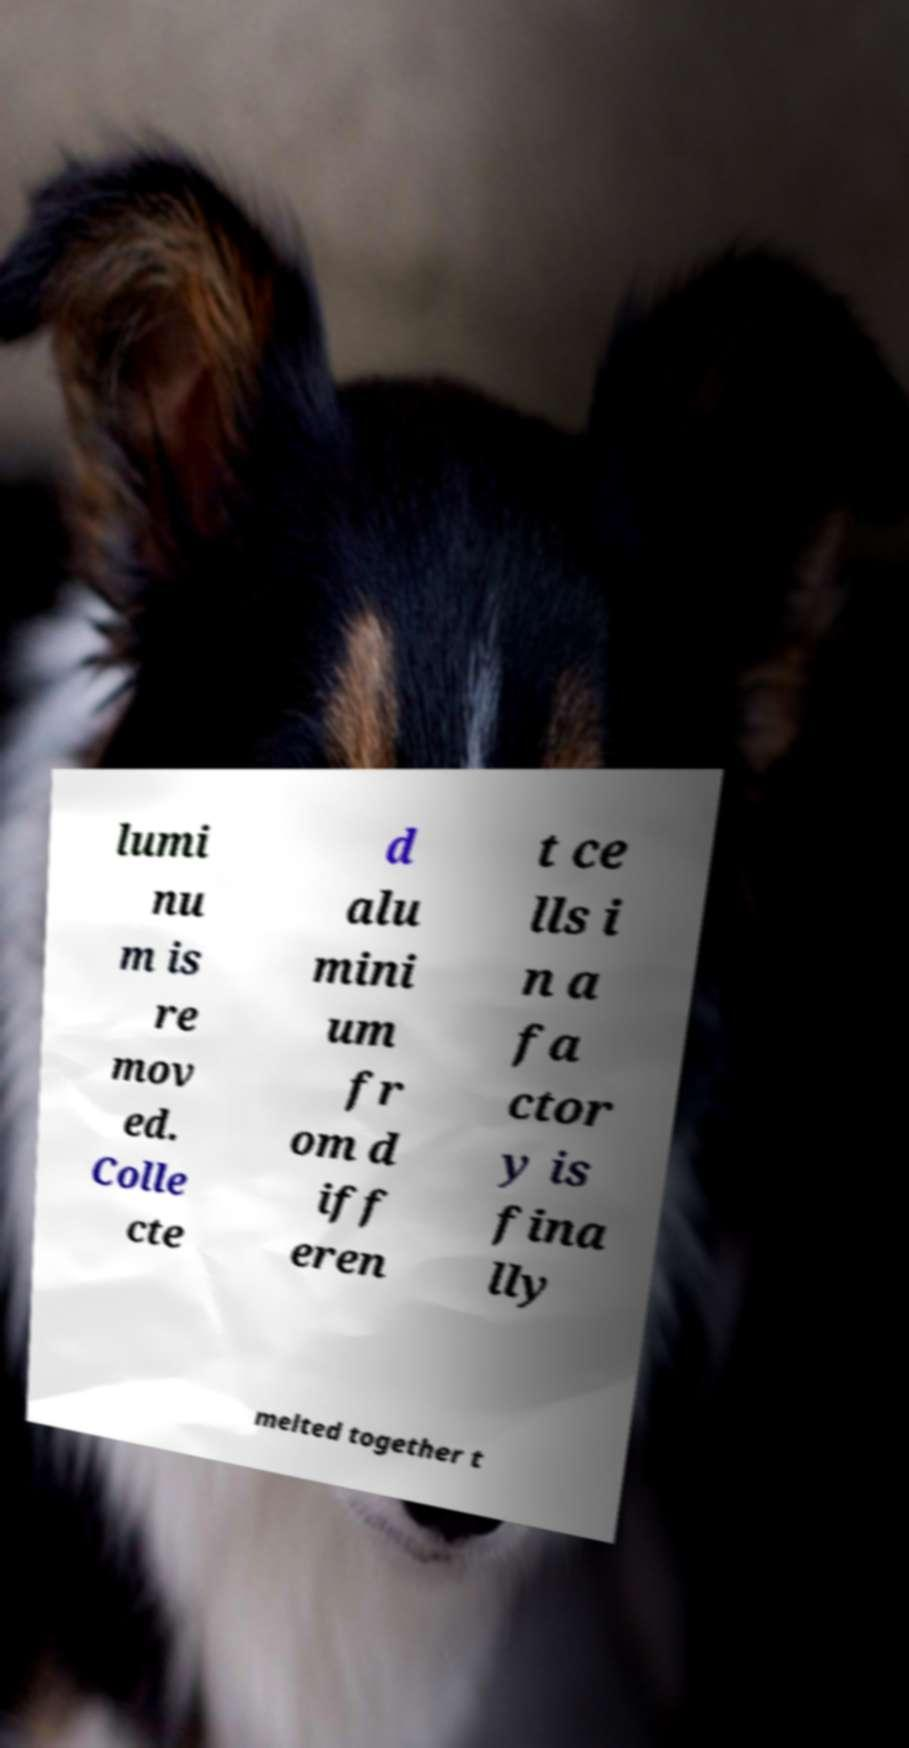Please read and relay the text visible in this image. What does it say? lumi nu m is re mov ed. Colle cte d alu mini um fr om d iff eren t ce lls i n a fa ctor y is fina lly melted together t 